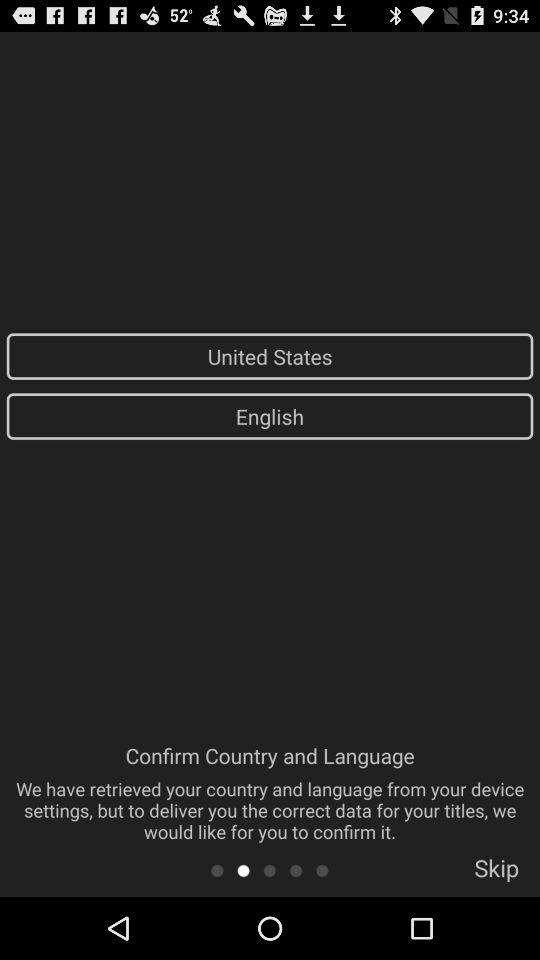What is the selected country? The selected country is the United States. 